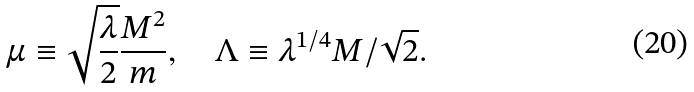<formula> <loc_0><loc_0><loc_500><loc_500>\mu \equiv \sqrt { \frac { \lambda } { 2 } } \frac { M ^ { 2 } } { m } , \quad \Lambda \equiv \lambda ^ { 1 / 4 } M / \sqrt { 2 } .</formula> 